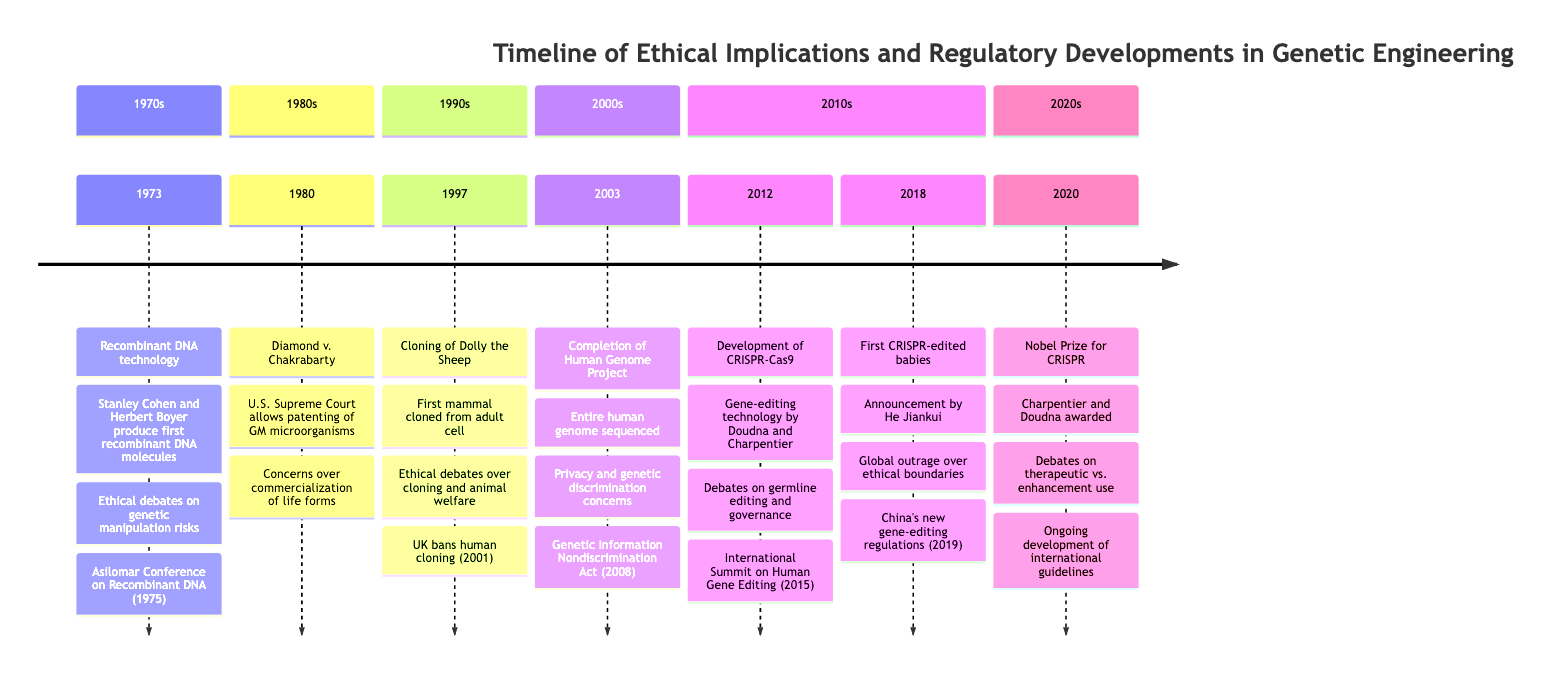What significant event in genetic engineering occurred in 1973? The diagram states that in 1973, the significant event was the production of the first recombinant DNA molecules by Stanley Cohen and Herbert Boyer.
Answer: Recombinant DNA technology What ethical implication was raised by the cloning of Dolly the Sheep in 1997? The timeline lists several ethical implications associated with the cloning of Dolly the Sheep, one of which is the ethical debates over cloning.
Answer: Ethical debates over cloning What regulatory development followed the announcement of the first CRISPR-edited babies in 2018? The timeline indicates that after the announcement of the first CRISPR-edited babies, China's new gene-editing regulations were introduced in 2019.
Answer: China's new gene-editing regulations (2019) In which year did the Nobel Prize in Chemistry for CRISPR get awarded? The diagram shows the year 2020 as when Emmanuelle Charpentier and Jennifer Doudna received the Nobel Prize in Chemistry for their work on CRISPR.
Answer: 2020 What ethical concern is associated with the completion of the Human Genome Project in 2003? The timeline lists privacy issues related to genetic information as an ethical concern associated with the completion of the Human Genome Project.
Answer: Privacy issues related to genetic information How many years apart were the events of the Asilomar Conference and Diamond v. Chakrabarty? The Asilomar Conference took place in 1975, two years after the 1973 event of Recombinant DNA technology, and Diamond v. Chakrabarty occurred in 1980. Thus, the two events are 5 years apart.
Answer: 5 What was a notable outcome of the Diamond v. Chakrabarty case in 1980? The timeline highlights that a notable outcome of this case was the court ruling that set a precedent for biotechnology patents.
Answer: Court ruling sets precedent for biotechnology patents What main ethical implication arose from the development of CRISPR-Cas9 in 2012? The timeline indicates that one main ethical implication from the development of CRISPR-Cas9 is the prospects of germline editing.
Answer: Prospects of germline editing Which regulatory development took place after the completion of the Human Genome Project and addresses genetic discrimination? According to the timeline, the Genetic Information Nondiscrimination Act (GINA) was enacted in 2008 after the completion of the Human Genome Project in 2003 to address genetic discrimination.
Answer: Genetic Information Nondiscrimination Act (GINA) 